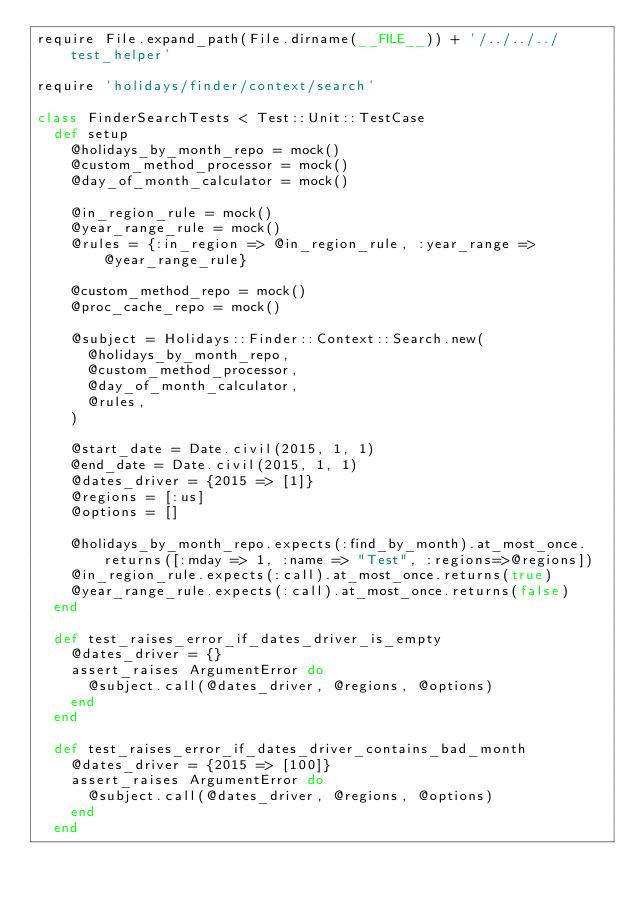Convert code to text. <code><loc_0><loc_0><loc_500><loc_500><_Ruby_>require File.expand_path(File.dirname(__FILE__)) + '/../../../test_helper'

require 'holidays/finder/context/search'

class FinderSearchTests < Test::Unit::TestCase
  def setup
    @holidays_by_month_repo = mock()
    @custom_method_processor = mock()
    @day_of_month_calculator = mock()

    @in_region_rule = mock()
    @year_range_rule = mock()
    @rules = {:in_region => @in_region_rule, :year_range => @year_range_rule}

    @custom_method_repo = mock()
    @proc_cache_repo = mock()

    @subject = Holidays::Finder::Context::Search.new(
      @holidays_by_month_repo,
      @custom_method_processor,
      @day_of_month_calculator,
      @rules,
    )

    @start_date = Date.civil(2015, 1, 1)
    @end_date = Date.civil(2015, 1, 1)
    @dates_driver = {2015 => [1]}
    @regions = [:us]
    @options = []

    @holidays_by_month_repo.expects(:find_by_month).at_most_once.returns([:mday => 1, :name => "Test", :regions=>@regions])
    @in_region_rule.expects(:call).at_most_once.returns(true)
    @year_range_rule.expects(:call).at_most_once.returns(false)
  end

  def test_raises_error_if_dates_driver_is_empty
    @dates_driver = {}
    assert_raises ArgumentError do
      @subject.call(@dates_driver, @regions, @options)
    end
  end

  def test_raises_error_if_dates_driver_contains_bad_month
    @dates_driver = {2015 => [100]}
    assert_raises ArgumentError do
      @subject.call(@dates_driver, @regions, @options)
    end
  end
</code> 